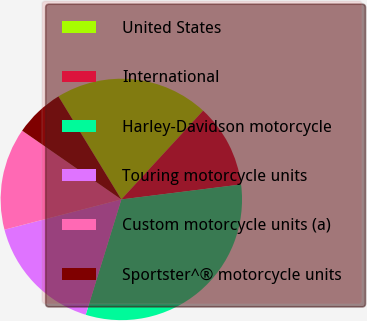Convert chart. <chart><loc_0><loc_0><loc_500><loc_500><pie_chart><fcel>United States<fcel>International<fcel>Harley-Davidson motorcycle<fcel>Touring motorcycle units<fcel>Custom motorcycle units (a)<fcel>Sportster^® motorcycle units<nl><fcel>20.57%<fcel>11.17%<fcel>31.75%<fcel>16.2%<fcel>13.68%<fcel>6.63%<nl></chart> 